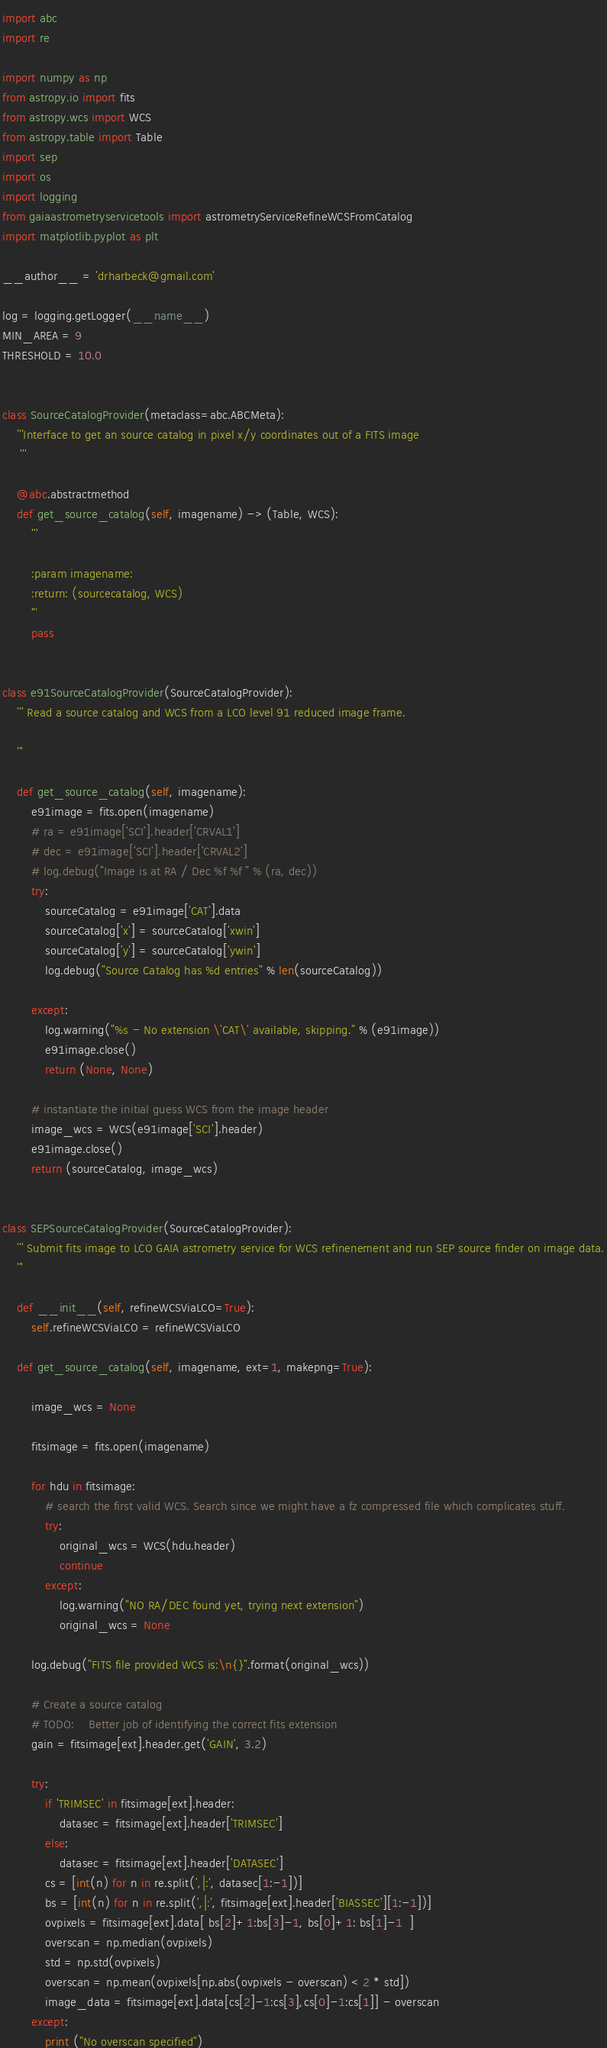Convert code to text. <code><loc_0><loc_0><loc_500><loc_500><_Python_>import abc
import re

import numpy as np
from astropy.io import fits
from astropy.wcs import WCS
from astropy.table import Table
import sep
import os
import logging
from gaiaastrometryservicetools import astrometryServiceRefineWCSFromCatalog
import matplotlib.pyplot as plt

__author__ = 'drharbeck@gmail.com'

log = logging.getLogger(__name__)
MIN_AREA = 9
THRESHOLD = 10.0


class SourceCatalogProvider(metaclass=abc.ABCMeta):
    '''Interface to get an source catalog in pixel x/y coordinates out of a FITS image
     '''

    @abc.abstractmethod
    def get_source_catalog(self, imagename) -> (Table, WCS):
        '''

        :param imagename:
        :return: (sourcecatalog, WCS)
        '''
        pass


class e91SourceCatalogProvider(SourceCatalogProvider):
    ''' Read a source catalog and WCS from a LCO level 91 reduced image frame.

    '''

    def get_source_catalog(self, imagename):
        e91image = fits.open(imagename)
        # ra = e91image['SCI'].header['CRVAL1']
        # dec = e91image['SCI'].header['CRVAL2']
        # log.debug("Image is at RA / Dec %f %f " % (ra, dec))
        try:
            sourceCatalog = e91image['CAT'].data
            sourceCatalog['x'] = sourceCatalog['xwin']
            sourceCatalog['y'] = sourceCatalog['ywin']
            log.debug("Source Catalog has %d entries" % len(sourceCatalog))

        except:
            log.warning("%s - No extension \'CAT\' available, skipping." % (e91image))
            e91image.close()
            return (None, None)

        # instantiate the initial guess WCS from the image header
        image_wcs = WCS(e91image['SCI'].header)
        e91image.close()
        return (sourceCatalog, image_wcs)


class SEPSourceCatalogProvider(SourceCatalogProvider):
    ''' Submit fits image to LCO GAIA astrometry service for WCS refinenement and run SEP source finder on image data.
    '''

    def __init__(self, refineWCSViaLCO=True):
        self.refineWCSViaLCO = refineWCSViaLCO

    def get_source_catalog(self, imagename, ext=1, makepng=True):

        image_wcs = None

        fitsimage = fits.open(imagename)

        for hdu in fitsimage:
            # search the first valid WCS. Search since we might have a fz compressed file which complicates stuff.
            try:
                original_wcs = WCS(hdu.header)
                continue
            except:
                log.warning("NO RA/DEC found yet, trying next extension")
                original_wcs = None

        log.debug("FITS file provided WCS is:\n{}".format(original_wcs))

        # Create a source catalog
        # TODO:    Better job of identifying the correct fits extension
        gain = fitsimage[ext].header.get('GAIN', 3.2)

        try:
            if 'TRIMSEC' in fitsimage[ext].header:
                datasec = fitsimage[ext].header['TRIMSEC']
            else:
                datasec = fitsimage[ext].header['DATASEC']
            cs = [int(n) for n in re.split(',|:', datasec[1:-1])]
            bs = [int(n) for n in re.split(',|:', fitsimage[ext].header['BIASSEC'][1:-1])]
            ovpixels = fitsimage[ext].data[ bs[2]+1:bs[3]-1, bs[0]+1: bs[1]-1  ]
            overscan = np.median(ovpixels)
            std = np.std(ovpixels)
            overscan = np.mean(ovpixels[np.abs(ovpixels - overscan) < 2 * std])
            image_data = fitsimage[ext].data[cs[2]-1:cs[3],cs[0]-1:cs[1]] - overscan
        except:
            print ("No overscan specified")</code> 